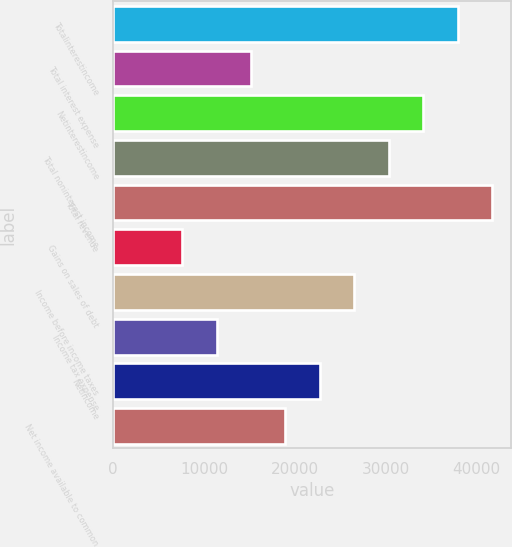<chart> <loc_0><loc_0><loc_500><loc_500><bar_chart><fcel>Totalinterestincome<fcel>Total interest expense<fcel>Netinterestincome<fcel>Total noninterest income<fcel>Total revenue<fcel>Gains on sales of debt<fcel>Income before income taxes<fcel>Income tax expense<fcel>Netincome<fcel>Net income available to common<nl><fcel>37914<fcel>15167.7<fcel>34122.9<fcel>30331.9<fcel>41705<fcel>7585.65<fcel>26540.8<fcel>11376.7<fcel>22749.8<fcel>18958.8<nl></chart> 